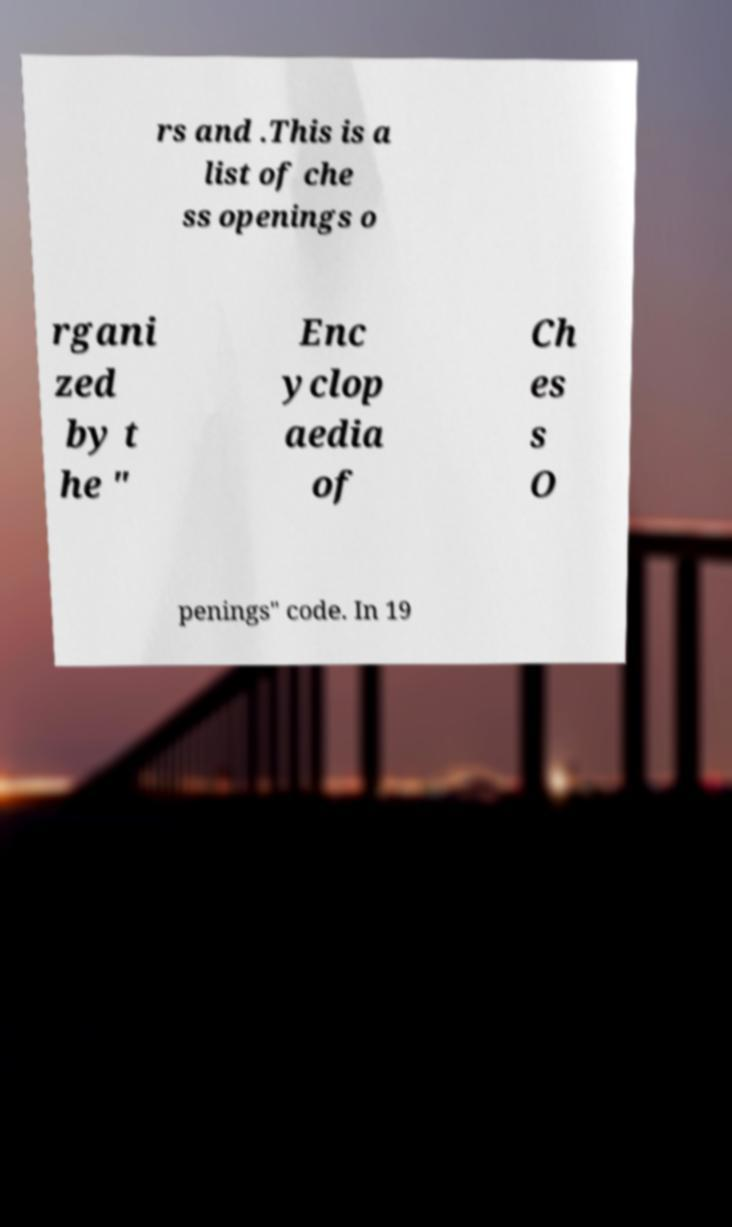Could you assist in decoding the text presented in this image and type it out clearly? rs and .This is a list of che ss openings o rgani zed by t he " Enc yclop aedia of Ch es s O penings" code. In 19 